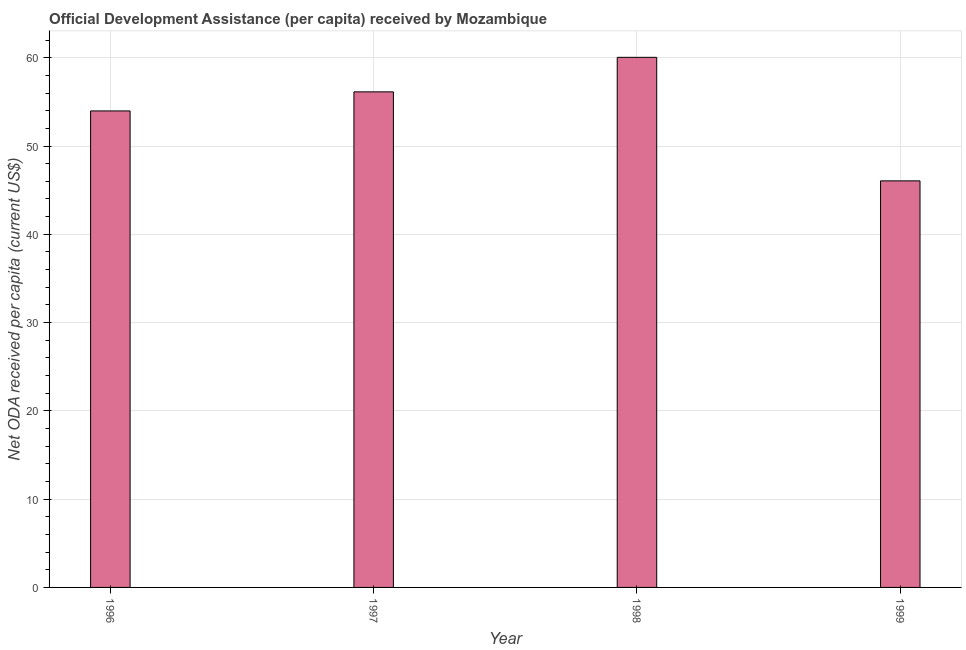Does the graph contain grids?
Give a very brief answer. Yes. What is the title of the graph?
Keep it short and to the point. Official Development Assistance (per capita) received by Mozambique. What is the label or title of the X-axis?
Offer a very short reply. Year. What is the label or title of the Y-axis?
Your answer should be compact. Net ODA received per capita (current US$). What is the net oda received per capita in 1999?
Provide a short and direct response. 46.05. Across all years, what is the maximum net oda received per capita?
Keep it short and to the point. 60.04. Across all years, what is the minimum net oda received per capita?
Keep it short and to the point. 46.05. What is the sum of the net oda received per capita?
Your answer should be very brief. 216.2. What is the difference between the net oda received per capita in 1996 and 1998?
Give a very brief answer. -6.07. What is the average net oda received per capita per year?
Ensure brevity in your answer.  54.05. What is the median net oda received per capita?
Your response must be concise. 55.05. In how many years, is the net oda received per capita greater than 30 US$?
Keep it short and to the point. 4. What is the ratio of the net oda received per capita in 1996 to that in 1999?
Your response must be concise. 1.17. What is the difference between the highest and the second highest net oda received per capita?
Your response must be concise. 3.91. What is the difference between the highest and the lowest net oda received per capita?
Offer a very short reply. 13.99. In how many years, is the net oda received per capita greater than the average net oda received per capita taken over all years?
Your answer should be very brief. 2. Are all the bars in the graph horizontal?
Your answer should be very brief. No. How many years are there in the graph?
Give a very brief answer. 4. What is the difference between two consecutive major ticks on the Y-axis?
Give a very brief answer. 10. Are the values on the major ticks of Y-axis written in scientific E-notation?
Offer a very short reply. No. What is the Net ODA received per capita (current US$) of 1996?
Keep it short and to the point. 53.97. What is the Net ODA received per capita (current US$) of 1997?
Provide a short and direct response. 56.13. What is the Net ODA received per capita (current US$) of 1998?
Ensure brevity in your answer.  60.04. What is the Net ODA received per capita (current US$) of 1999?
Your answer should be very brief. 46.05. What is the difference between the Net ODA received per capita (current US$) in 1996 and 1997?
Provide a succinct answer. -2.16. What is the difference between the Net ODA received per capita (current US$) in 1996 and 1998?
Provide a succinct answer. -6.07. What is the difference between the Net ODA received per capita (current US$) in 1996 and 1999?
Give a very brief answer. 7.92. What is the difference between the Net ODA received per capita (current US$) in 1997 and 1998?
Offer a terse response. -3.91. What is the difference between the Net ODA received per capita (current US$) in 1997 and 1999?
Your answer should be compact. 10.08. What is the difference between the Net ODA received per capita (current US$) in 1998 and 1999?
Provide a short and direct response. 13.99. What is the ratio of the Net ODA received per capita (current US$) in 1996 to that in 1997?
Your response must be concise. 0.96. What is the ratio of the Net ODA received per capita (current US$) in 1996 to that in 1998?
Offer a terse response. 0.9. What is the ratio of the Net ODA received per capita (current US$) in 1996 to that in 1999?
Your answer should be compact. 1.17. What is the ratio of the Net ODA received per capita (current US$) in 1997 to that in 1998?
Keep it short and to the point. 0.94. What is the ratio of the Net ODA received per capita (current US$) in 1997 to that in 1999?
Give a very brief answer. 1.22. What is the ratio of the Net ODA received per capita (current US$) in 1998 to that in 1999?
Your answer should be very brief. 1.3. 